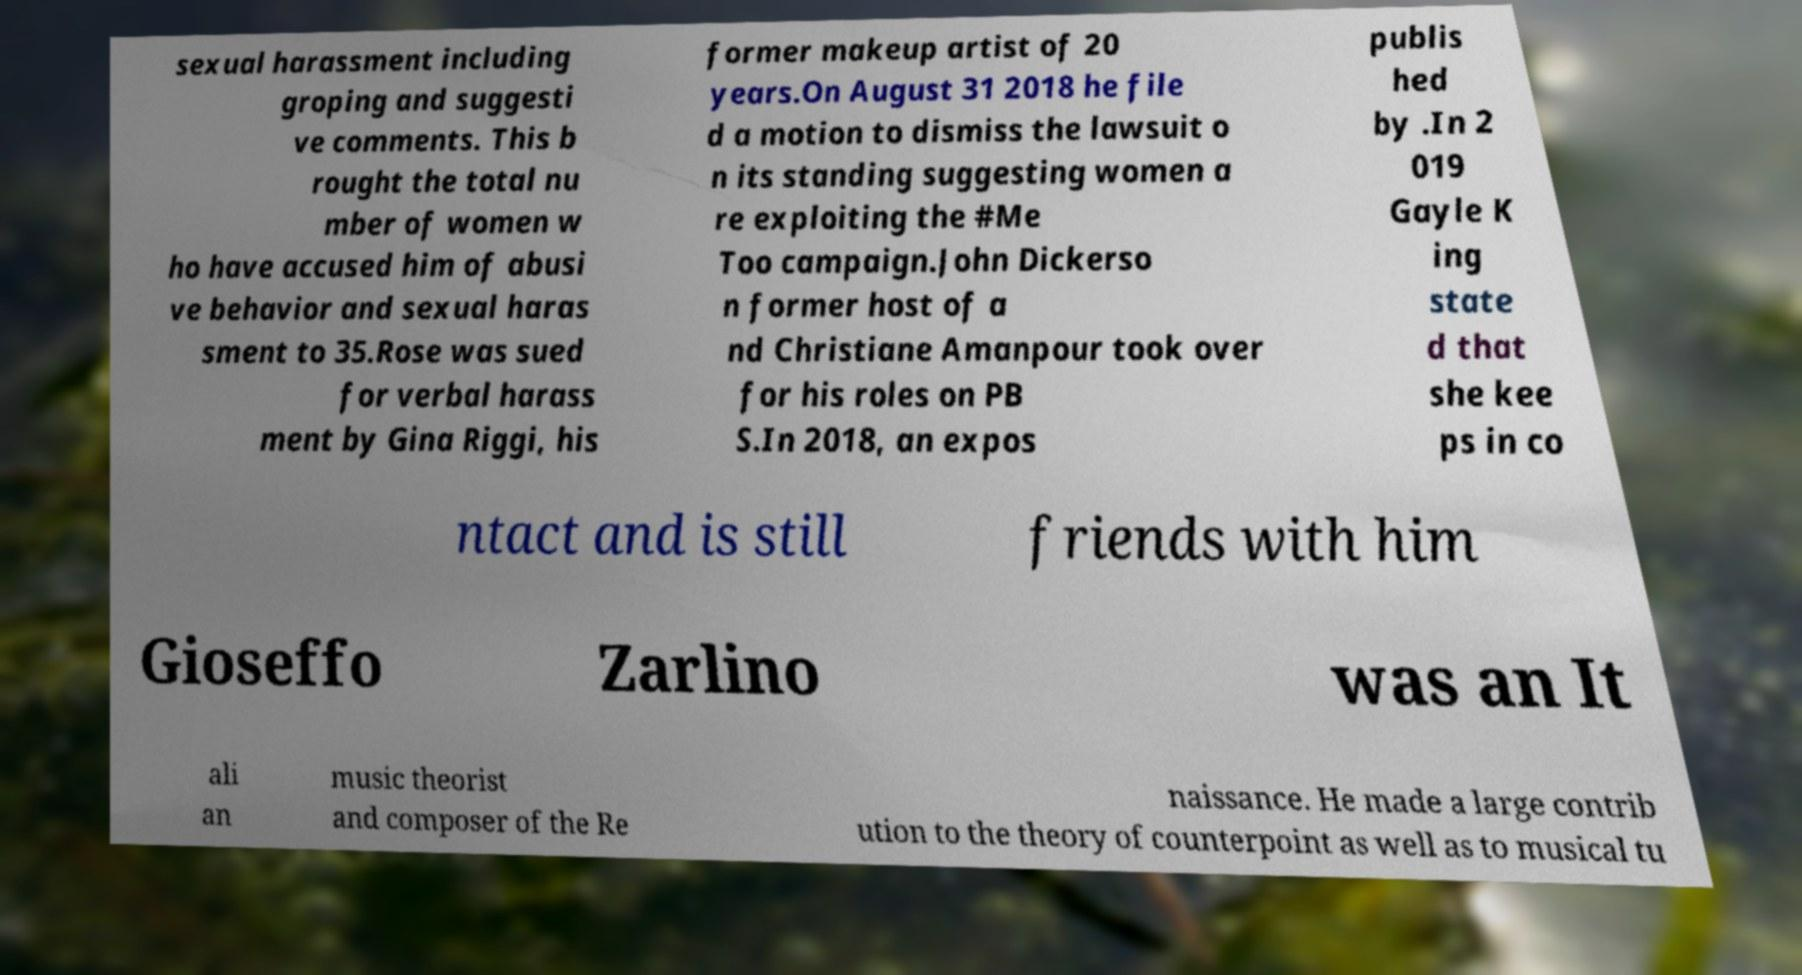Please identify and transcribe the text found in this image. sexual harassment including groping and suggesti ve comments. This b rought the total nu mber of women w ho have accused him of abusi ve behavior and sexual haras sment to 35.Rose was sued for verbal harass ment by Gina Riggi, his former makeup artist of 20 years.On August 31 2018 he file d a motion to dismiss the lawsuit o n its standing suggesting women a re exploiting the #Me Too campaign.John Dickerso n former host of a nd Christiane Amanpour took over for his roles on PB S.In 2018, an expos publis hed by .In 2 019 Gayle K ing state d that she kee ps in co ntact and is still friends with him Gioseffo Zarlino was an It ali an music theorist and composer of the Re naissance. He made a large contrib ution to the theory of counterpoint as well as to musical tu 